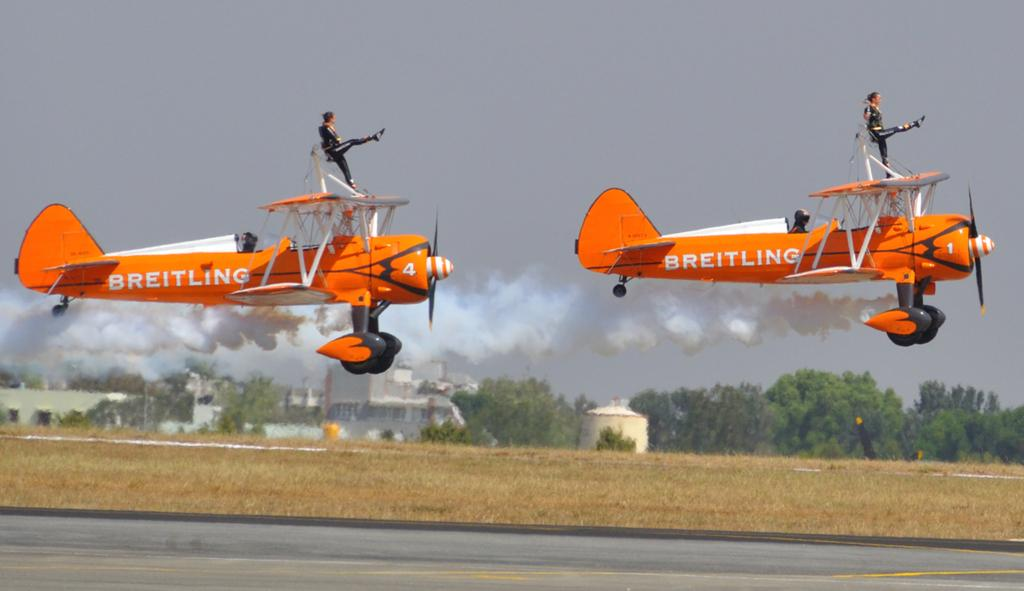<image>
Render a clear and concise summary of the photo. a plane that has the word Breitling on the side of it 